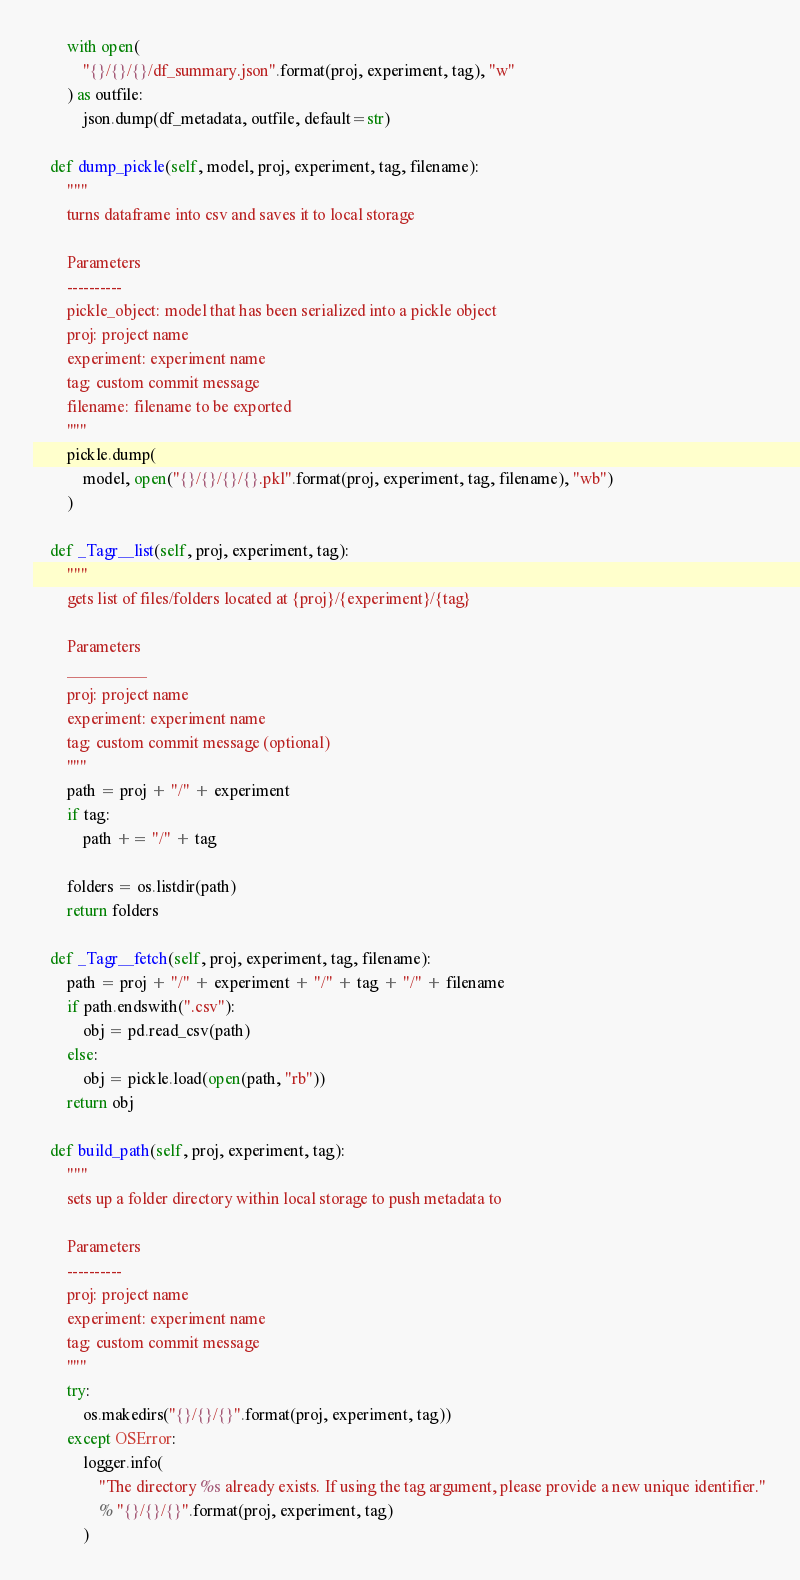<code> <loc_0><loc_0><loc_500><loc_500><_Python_>        with open(
            "{}/{}/{}/df_summary.json".format(proj, experiment, tag), "w"
        ) as outfile:
            json.dump(df_metadata, outfile, default=str)

    def dump_pickle(self, model, proj, experiment, tag, filename):
        """
        turns dataframe into csv and saves it to local storage

        Parameters
        ----------
        pickle_object: model that has been serialized into a pickle object
        proj: project name
        experiment: experiment name
        tag: custom commit message
        filename: filename to be exported
        """
        pickle.dump(
            model, open("{}/{}/{}/{}.pkl".format(proj, experiment, tag, filename), "wb")
        )

    def _Tagr__list(self, proj, experiment, tag):
        """
        gets list of files/folders located at {proj}/{experiment}/{tag}

        Parameters
        __________
        proj: project name
        experiment: experiment name
        tag: custom commit message (optional)
        """
        path = proj + "/" + experiment
        if tag:
            path += "/" + tag

        folders = os.listdir(path)
        return folders

    def _Tagr__fetch(self, proj, experiment, tag, filename):
        path = proj + "/" + experiment + "/" + tag + "/" + filename
        if path.endswith(".csv"):
            obj = pd.read_csv(path)
        else:
            obj = pickle.load(open(path, "rb"))
        return obj

    def build_path(self, proj, experiment, tag):
        """
        sets up a folder directory within local storage to push metadata to

        Parameters
        ----------
        proj: project name
        experiment: experiment name
        tag: custom commit message
        """
        try:
            os.makedirs("{}/{}/{}".format(proj, experiment, tag))
        except OSError:
            logger.info(
                "The directory %s already exists. If using the tag argument, please provide a new unique identifier."
                % "{}/{}/{}".format(proj, experiment, tag)
            )
</code> 